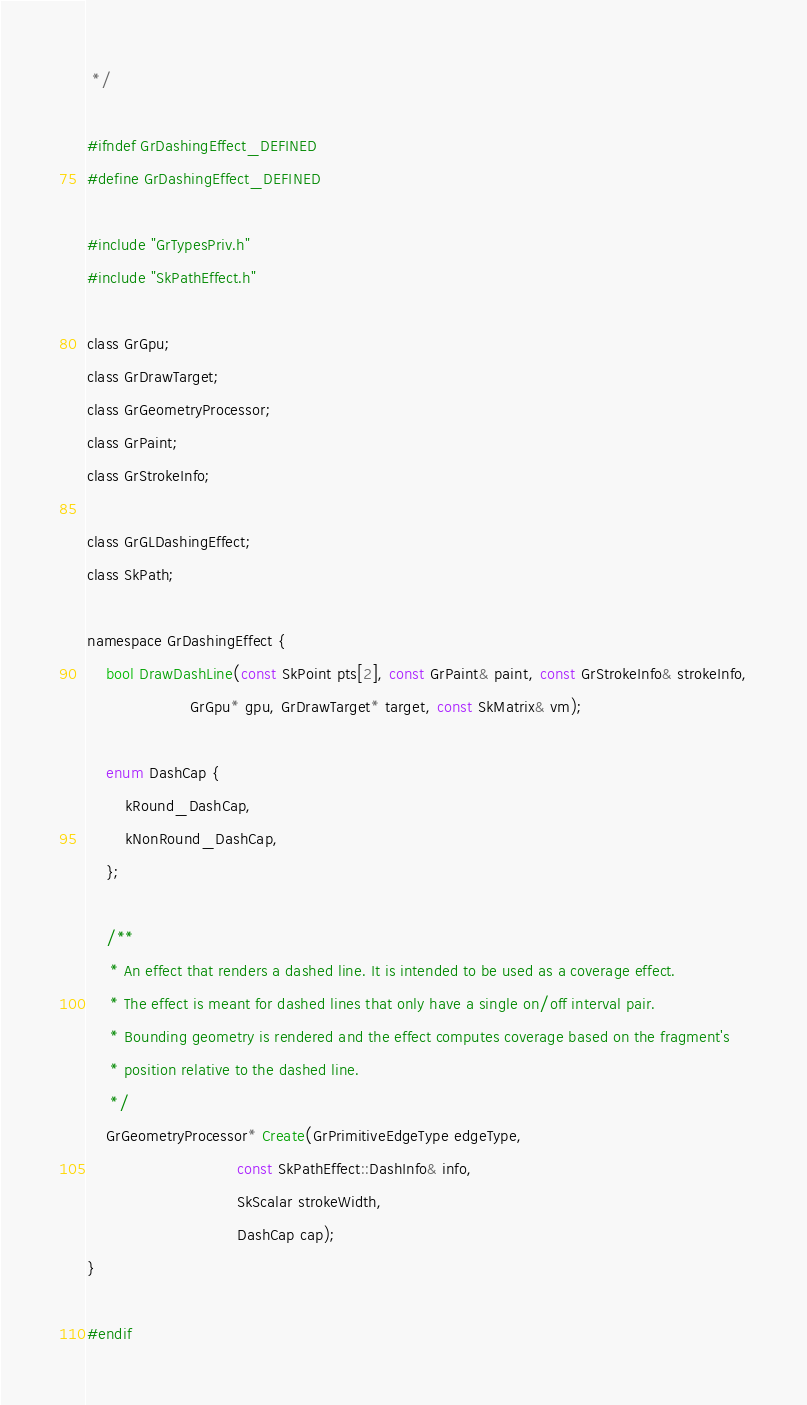Convert code to text. <code><loc_0><loc_0><loc_500><loc_500><_C_> */

#ifndef GrDashingEffect_DEFINED
#define GrDashingEffect_DEFINED

#include "GrTypesPriv.h"
#include "SkPathEffect.h"

class GrGpu;
class GrDrawTarget;
class GrGeometryProcessor;
class GrPaint;
class GrStrokeInfo;

class GrGLDashingEffect;
class SkPath;

namespace GrDashingEffect {
    bool DrawDashLine(const SkPoint pts[2], const GrPaint& paint, const GrStrokeInfo& strokeInfo,
                      GrGpu* gpu, GrDrawTarget* target, const SkMatrix& vm);

    enum DashCap {
        kRound_DashCap,
        kNonRound_DashCap,
    };

    /**
     * An effect that renders a dashed line. It is intended to be used as a coverage effect.
     * The effect is meant for dashed lines that only have a single on/off interval pair.
     * Bounding geometry is rendered and the effect computes coverage based on the fragment's
     * position relative to the dashed line.
     */
    GrGeometryProcessor* Create(GrPrimitiveEdgeType edgeType,
                                const SkPathEffect::DashInfo& info,
                                SkScalar strokeWidth,
                                DashCap cap);
}

#endif
</code> 